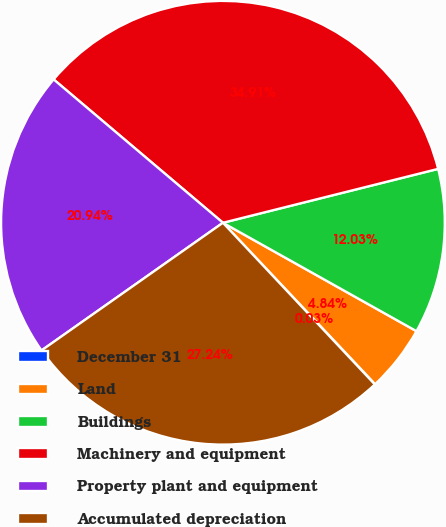Convert chart. <chart><loc_0><loc_0><loc_500><loc_500><pie_chart><fcel>December 31<fcel>Land<fcel>Buildings<fcel>Machinery and equipment<fcel>Property plant and equipment<fcel>Accumulated depreciation<nl><fcel>0.03%<fcel>4.84%<fcel>12.03%<fcel>34.91%<fcel>20.94%<fcel>27.24%<nl></chart> 